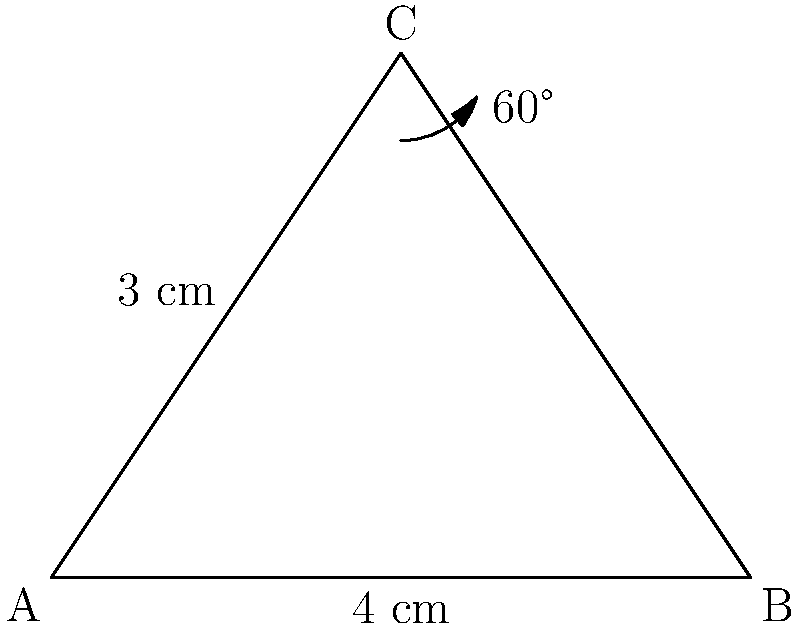A triangular slice of pie has a base of 4 cm and a height of 3 cm. If the angle at the top of the slice is 60°, what is the volume of the pie slice, assuming it has a uniform thickness of 2 cm? Let's approach this step-by-step:

1) First, we need to find the area of the triangular face of the pie slice. We can use the formula for the area of a triangle:

   Area = $\frac{1}{2} \times$ base $\times$ height

2) We're given:
   Base = 4 cm
   Height = 3 cm

3) Plugging these into our formula:

   Area = $\frac{1}{2} \times 4 \times 3 = 6$ cm²

4) Now that we have the area of the triangular face, we can find the volume by multiplying this area by the thickness of the slice:

   Volume = Area $\times$ Thickness

5) We're given that the thickness is 2 cm, so:

   Volume = 6 cm² $\times$ 2 cm = 12 cm³

Therefore, the volume of the pie slice is 12 cubic centimeters.
Answer: 12 cm³ 